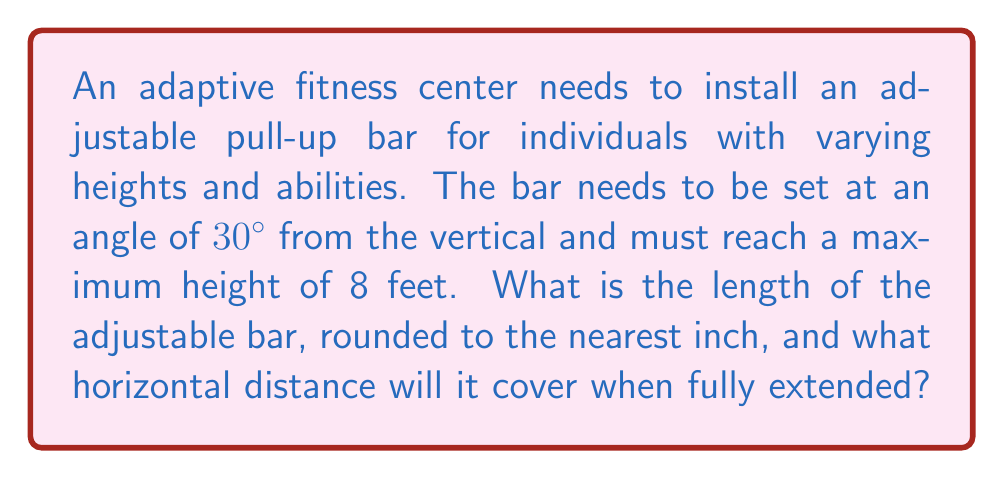Provide a solution to this math problem. Let's approach this step-by-step:

1) We can visualize this as a right triangle, where:
   - The hypotenuse is the adjustable bar
   - The vertical side is 8 feet (the maximum height)
   - The angle between the bar and the vertical is 30°

2) To find the length of the bar, we can use the cosine function:

   $\cos 30° = \frac{\text{adjacent}}{\text{hypotenuse}} = \frac{8}{\text{bar length}}$

3) Rearranging this equation:

   $\text{bar length} = \frac{8}{\cos 30°}$

4) We know that $\cos 30° = \frac{\sqrt{3}}{2}$, so:

   $\text{bar length} = \frac{8}{\frac{\sqrt{3}}{2}} = 8 \cdot \frac{2}{\sqrt{3}} = \frac{16}{\sqrt{3}}$

5) Simplifying:

   $\text{bar length} = \frac{16}{\sqrt{3}} \approx 9.238$ feet

6) Converting to inches and rounding to the nearest inch:

   $9.238 \text{ feet} \times 12 \text{ inches/foot} \approx 110.86 \text{ inches} \approx 111 \text{ inches}$

7) To find the horizontal distance, we can use the tangent function:

   $\tan 30° = \frac{\text{opposite}}{\text{adjacent}} = \frac{\text{horizontal distance}}{8}$

8) Rearranging:

   $\text{horizontal distance} = 8 \tan 30°$

9) We know that $\tan 30° = \frac{1}{\sqrt{3}}$, so:

   $\text{horizontal distance} = 8 \cdot \frac{1}{\sqrt{3}} = \frac{8}{\sqrt{3}} \approx 4.619$ feet

Therefore, the bar length is 111 inches, and it will cover a horizontal distance of approximately 4.619 feet when fully extended.
Answer: 111 inches; 4.619 feet 